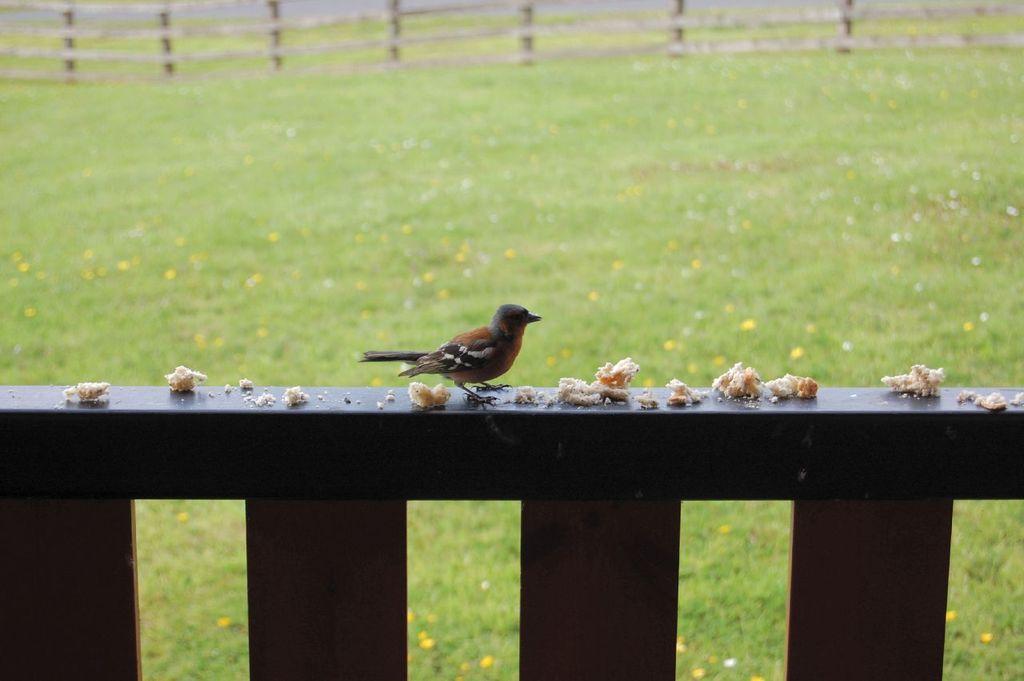Please provide a concise description of this image. In this picture we can observe a bird on the brown color railing. There is some food placed on the railing. The bird is in brown color. In the background we can observe a wooden railing. There is some grass on the ground. 